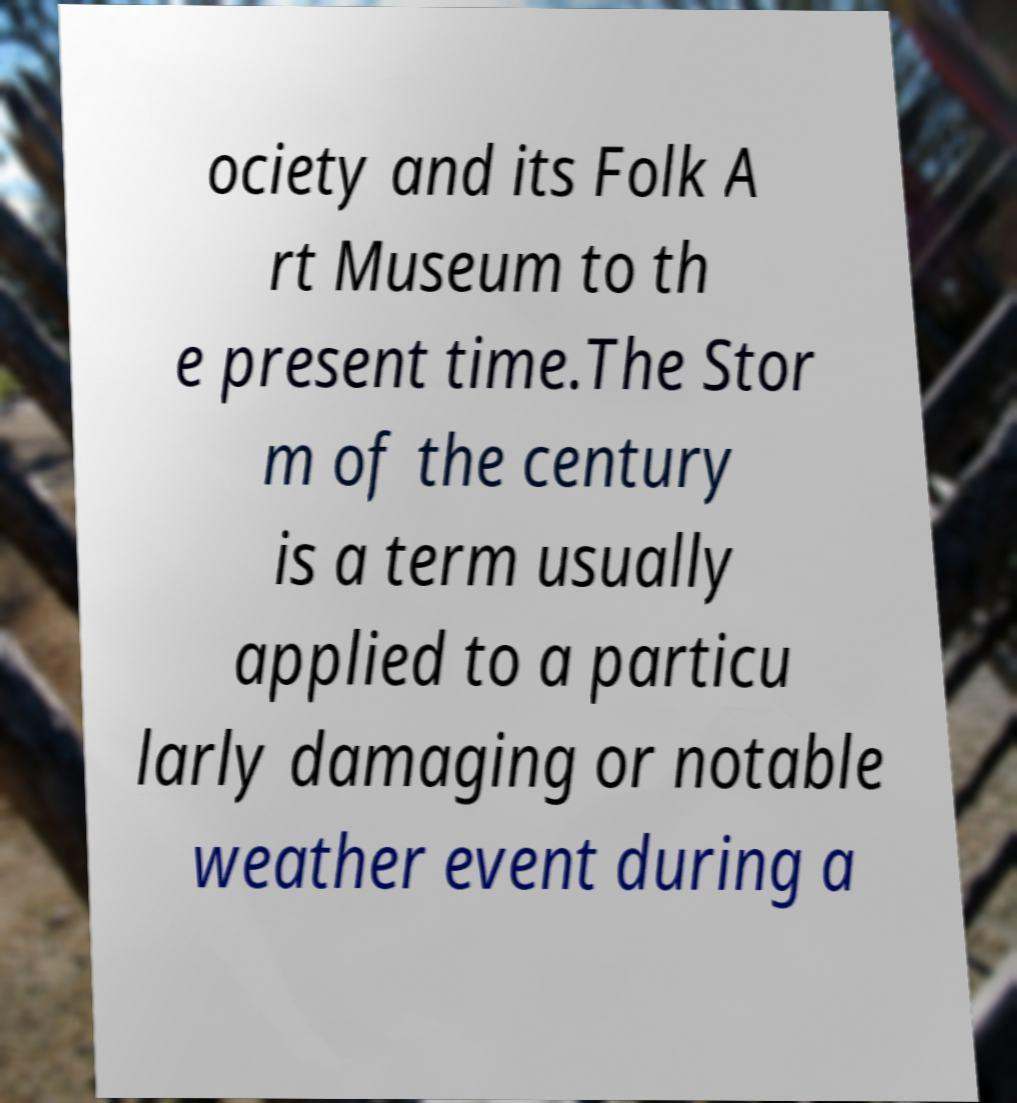What messages or text are displayed in this image? I need them in a readable, typed format. ociety and its Folk A rt Museum to th e present time.The Stor m of the century is a term usually applied to a particu larly damaging or notable weather event during a 